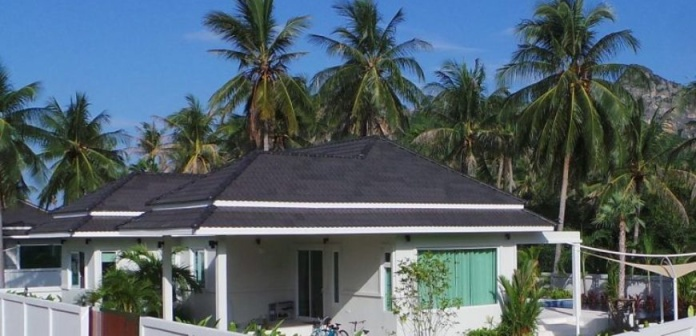Can you explore the significance of the bicycles in this setting? The presence of the bicycles leaning against the fence implies a casual, laid-back lifestyle indicative of the bungalow's inhabitants or visitors. Bicycles often symbolize leisure and eco-friendly transport options, particularly suitable for navigating the serene and less crowded paths typical of such a scenic area. They suggest that the people here appreciate outdoor activities and are likely embracing a relaxed pace of life, possibly exploring the scenic landscapes and local vicinity at a leisurely speed. 